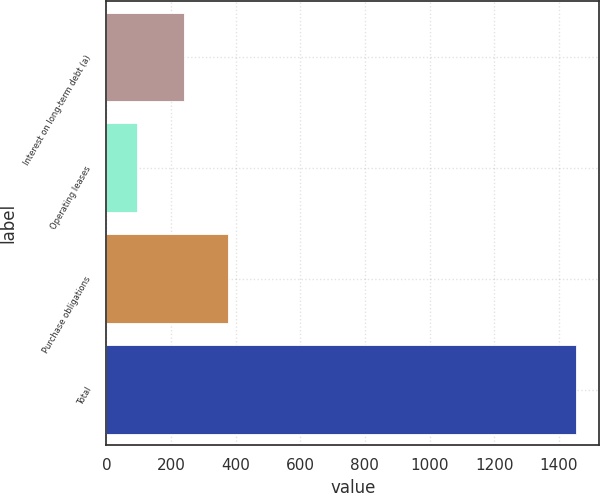<chart> <loc_0><loc_0><loc_500><loc_500><bar_chart><fcel>Interest on long-term debt (a)<fcel>Operating leases<fcel>Purchase obligations<fcel>Total<nl><fcel>241<fcel>94<fcel>376.9<fcel>1453<nl></chart> 